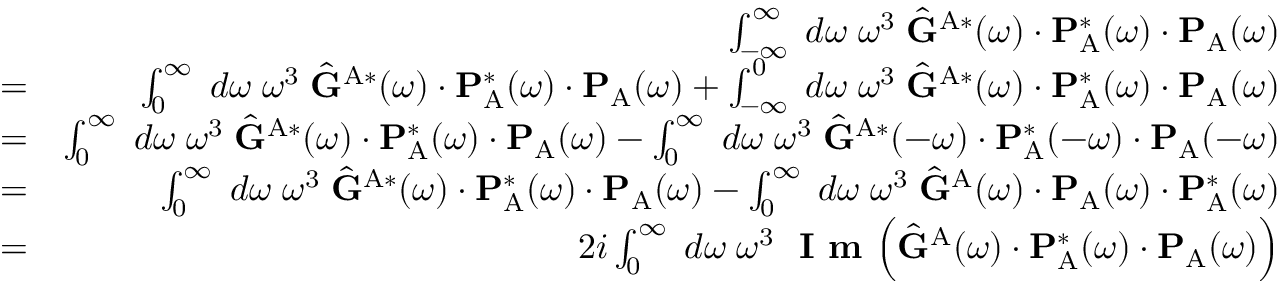<formula> <loc_0><loc_0><loc_500><loc_500>\begin{array} { r l r } & { \int _ { - \infty } ^ { \infty } \, d \omega \, \omega ^ { 3 } \, \hat { G } ^ { A * } ( \omega ) \cdot P _ { A } ^ { * } ( \omega ) \cdot P _ { A } ( \omega ) } \\ & { = } & { \int _ { 0 } ^ { \infty } \, d \omega \, \omega ^ { 3 } \, \hat { G } ^ { A * } ( \omega ) \cdot P _ { A } ^ { * } ( \omega ) \cdot P _ { A } ( \omega ) + \int _ { - \infty } ^ { 0 } \, d \omega \, \omega ^ { 3 } \, \hat { G } ^ { A * } ( \omega ) \cdot P _ { A } ^ { * } ( \omega ) \cdot P _ { A } ( \omega ) } \\ & { = } & { \int _ { 0 } ^ { \infty } \, d \omega \, \omega ^ { 3 } \, \hat { G } ^ { A * } ( \omega ) \cdot P _ { A } ^ { * } ( \omega ) \cdot P _ { A } ( \omega ) - \int _ { 0 } ^ { \infty } \, d \omega \, \omega ^ { 3 } \, \hat { G } ^ { A * } ( - \omega ) \cdot P _ { A } ^ { * } ( - \omega ) \cdot P _ { A } ( - \omega ) } \\ & { = } & { \int _ { 0 } ^ { \infty } \, d \omega \, \omega ^ { 3 } \, \hat { G } ^ { A * } ( \omega ) \cdot P _ { A } ^ { * } ( \omega ) \cdot P _ { A } ( \omega ) - \int _ { 0 } ^ { \infty } \, d \omega \, \omega ^ { 3 } \, \hat { G } ^ { A } ( \omega ) \cdot P _ { A } ( \omega ) \cdot P _ { A } ^ { * } ( \omega ) } \\ & { = } & { 2 i \int _ { 0 } ^ { \infty } \, d \omega \, \omega ^ { 3 } \, I m \left ( \hat { G } ^ { A } ( \omega ) \cdot P _ { A } ^ { * } ( \omega ) \cdot P _ { A } ( \omega ) \right ) } \end{array}</formula> 